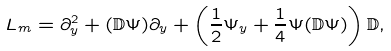<formula> <loc_0><loc_0><loc_500><loc_500>L _ { m } = \partial _ { y } ^ { 2 } + ( \mathbb { D } \Psi ) \partial _ { y } + \left ( \frac { 1 } { 2 } \Psi _ { y } + \frac { 1 } { 4 } \Psi ( \mathbb { D } \Psi ) \right ) \mathbb { D } ,</formula> 